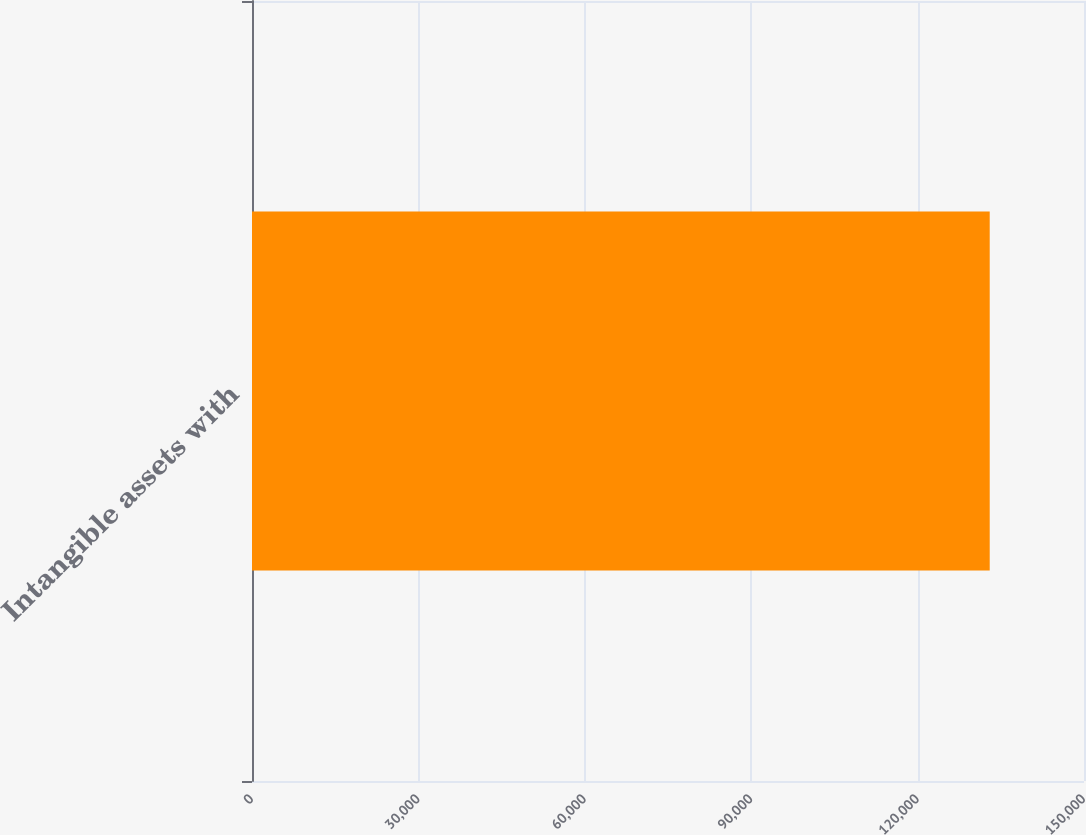Convert chart. <chart><loc_0><loc_0><loc_500><loc_500><bar_chart><fcel>Intangible assets with<nl><fcel>133003<nl></chart> 